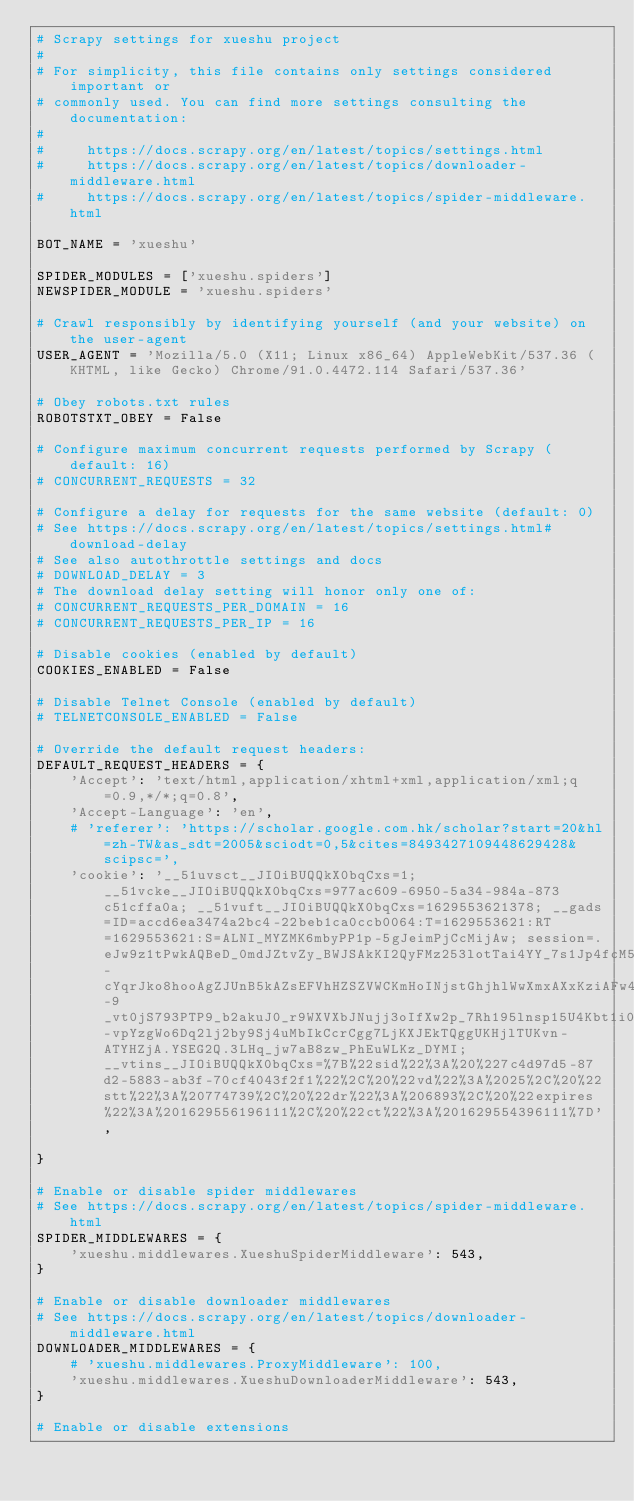<code> <loc_0><loc_0><loc_500><loc_500><_Python_># Scrapy settings for xueshu project
#
# For simplicity, this file contains only settings considered important or
# commonly used. You can find more settings consulting the documentation:
#
#     https://docs.scrapy.org/en/latest/topics/settings.html
#     https://docs.scrapy.org/en/latest/topics/downloader-middleware.html
#     https://docs.scrapy.org/en/latest/topics/spider-middleware.html

BOT_NAME = 'xueshu'

SPIDER_MODULES = ['xueshu.spiders']
NEWSPIDER_MODULE = 'xueshu.spiders'

# Crawl responsibly by identifying yourself (and your website) on the user-agent
USER_AGENT = 'Mozilla/5.0 (X11; Linux x86_64) AppleWebKit/537.36 (KHTML, like Gecko) Chrome/91.0.4472.114 Safari/537.36'

# Obey robots.txt rules
ROBOTSTXT_OBEY = False

# Configure maximum concurrent requests performed by Scrapy (default: 16)
# CONCURRENT_REQUESTS = 32

# Configure a delay for requests for the same website (default: 0)
# See https://docs.scrapy.org/en/latest/topics/settings.html#download-delay
# See also autothrottle settings and docs
# DOWNLOAD_DELAY = 3
# The download delay setting will honor only one of:
# CONCURRENT_REQUESTS_PER_DOMAIN = 16
# CONCURRENT_REQUESTS_PER_IP = 16

# Disable cookies (enabled by default)
COOKIES_ENABLED = False

# Disable Telnet Console (enabled by default)
# TELNETCONSOLE_ENABLED = False

# Override the default request headers:
DEFAULT_REQUEST_HEADERS = {
    'Accept': 'text/html,application/xhtml+xml,application/xml;q=0.9,*/*;q=0.8',
    'Accept-Language': 'en',
    # 'referer': 'https://scholar.google.com.hk/scholar?start=20&hl=zh-TW&as_sdt=2005&sciodt=0,5&cites=8493427109448629428&scipsc=',
    'cookie': '__51uvsct__JIOiBUQQkX0bqCxs=1; __51vcke__JIOiBUQQkX0bqCxs=977ac609-6950-5a34-984a-873c51cffa0a; __51vuft__JIOiBUQQkX0bqCxs=1629553621378; __gads=ID=accd6ea3474a2bc4-22beb1ca0ccb0064:T=1629553621:RT=1629553621:S=ALNI_MYZMK6mbyPP1p-5gJeimPjCcMijAw; session=.eJw9z1tPwkAQBeD_0mdJZtvZy_BWJSAkKI2QyFMz253lotTai4YY_7s1Jp4fcM53vpIyttIdk2nfDnKTlKeQTBPn2FQZ2UyhBw-cYqrJko8hooAgZJUnB5kAZsEFVhHZSZVWCKmHoINjstGhjhlWwXmxAXxKziAFw4zRjgUGQSkvyqmUowCx9yIqesNVMkIaaS9cS93_04ZO2j_fIf_N7XFZcGN8MykeF_k-9_vt0jS793PTP9_b2akuJ0_r9WXVXbJNujj3oIfXw2p_7Rh195lnsp15U4Kbt1i0d9E84Jw3u-vpYzgWo6Dq2lj2by9Sj4uMbIkCcrCgg7LjKXJEkTQggUKHjlTUKvn-ATYHZjA.YSEG2Q.3LHq_jw7aB8zw_PhEuWLKz_DYMI; __vtins__JIOiBUQQkX0bqCxs=%7B%22sid%22%3A%20%227c4d97d5-87d2-5883-ab3f-70cf4043f2f1%22%2C%20%22vd%22%3A%2025%2C%20%22stt%22%3A%20774739%2C%20%22dr%22%3A%206893%2C%20%22expires%22%3A%201629556196111%2C%20%22ct%22%3A%201629554396111%7D',

}

# Enable or disable spider middlewares
# See https://docs.scrapy.org/en/latest/topics/spider-middleware.html
SPIDER_MIDDLEWARES = {
    'xueshu.middlewares.XueshuSpiderMiddleware': 543,
}

# Enable or disable downloader middlewares
# See https://docs.scrapy.org/en/latest/topics/downloader-middleware.html
DOWNLOADER_MIDDLEWARES = {
    # 'xueshu.middlewares.ProxyMiddleware': 100,
    'xueshu.middlewares.XueshuDownloaderMiddleware': 543,
}

# Enable or disable extensions</code> 